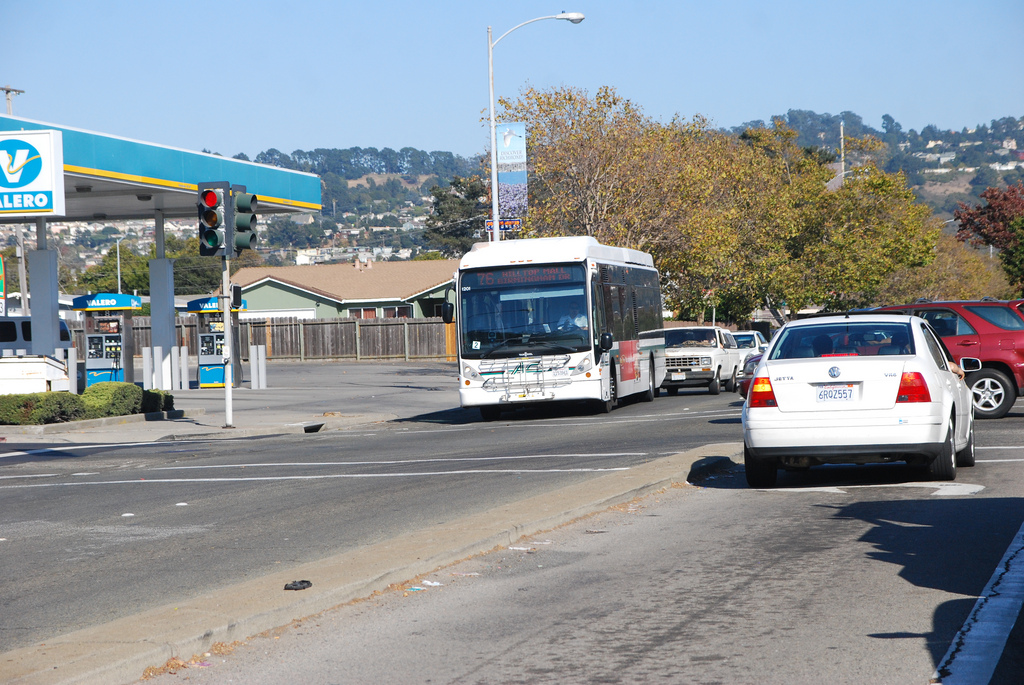Describe the landscape beyond the immediate scene. Beyond the immediate vicinity of the road and the structures, we can observe rolling hills with sparse residential areas, indicating a suburban landscape. 